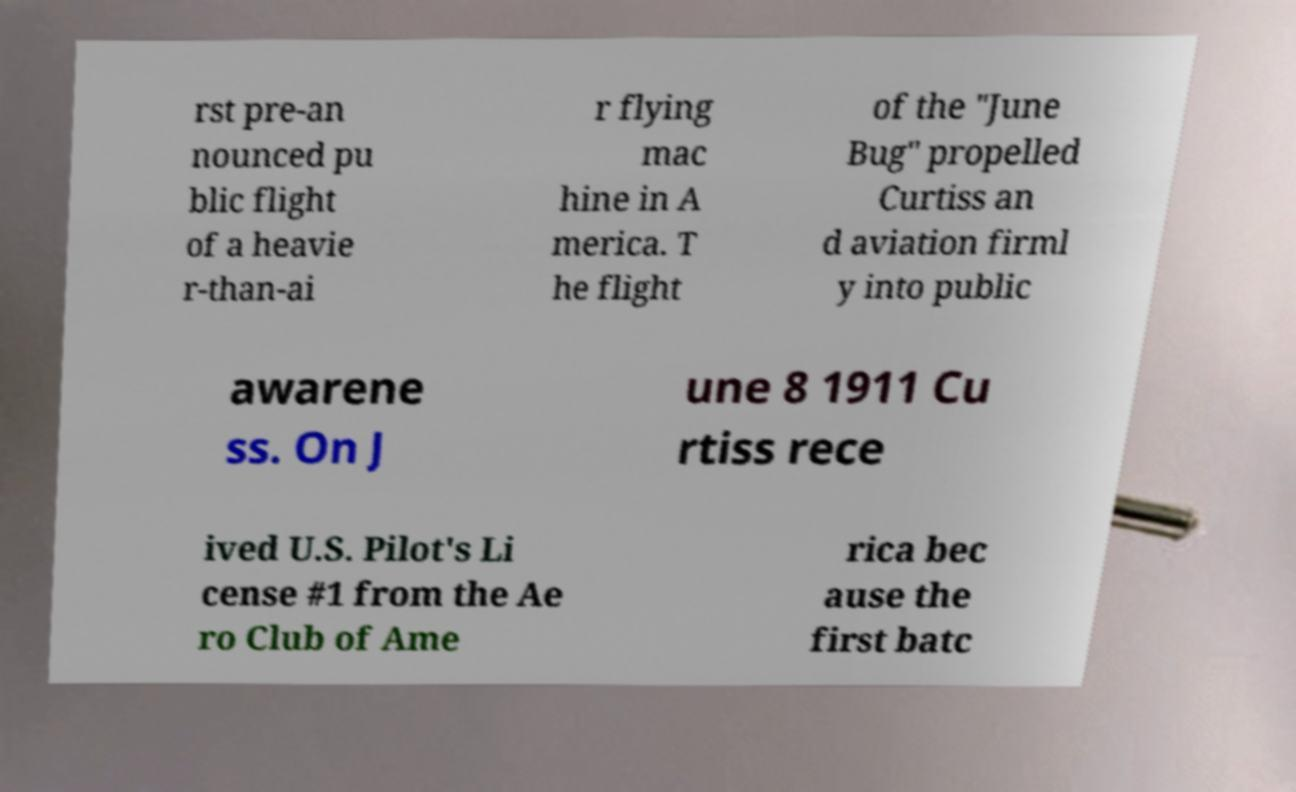What messages or text are displayed in this image? I need them in a readable, typed format. rst pre-an nounced pu blic flight of a heavie r-than-ai r flying mac hine in A merica. T he flight of the "June Bug" propelled Curtiss an d aviation firml y into public awarene ss. On J une 8 1911 Cu rtiss rece ived U.S. Pilot's Li cense #1 from the Ae ro Club of Ame rica bec ause the first batc 